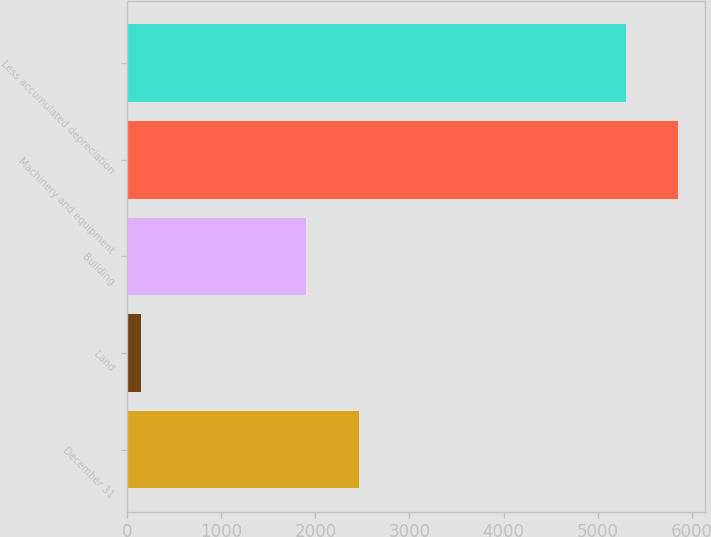Convert chart. <chart><loc_0><loc_0><loc_500><loc_500><bar_chart><fcel>December 31<fcel>Land<fcel>Building<fcel>Machinery and equipment<fcel>Less accumulated depreciation<nl><fcel>2458.9<fcel>148<fcel>1905<fcel>5851.9<fcel>5298<nl></chart> 